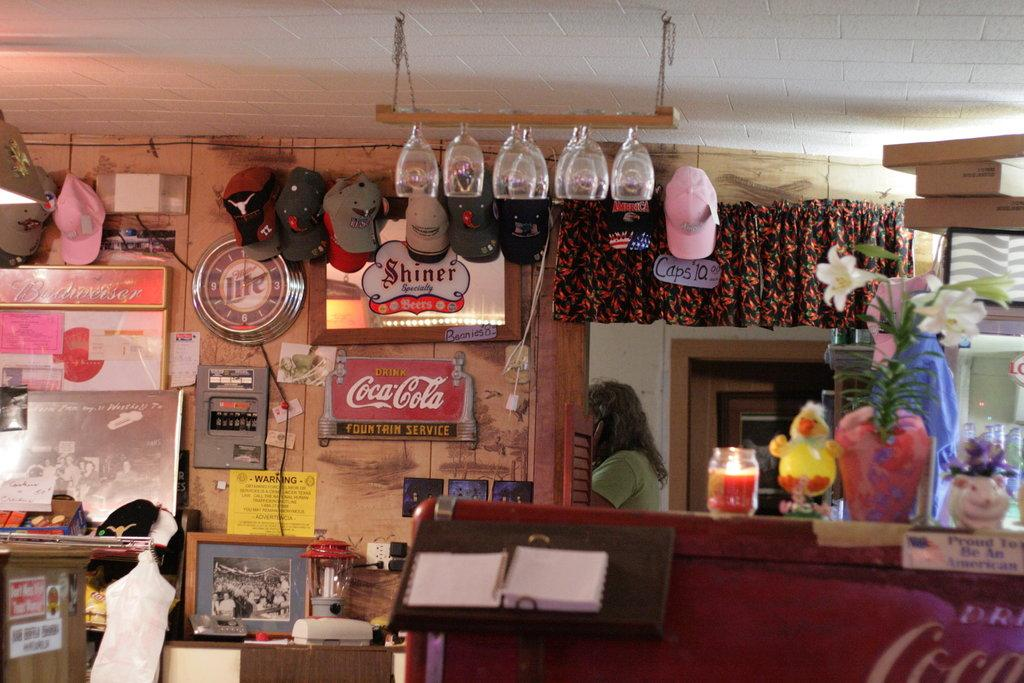<image>
Offer a succinct explanation of the picture presented. the store has a drink Coca Cola sign on the wall 